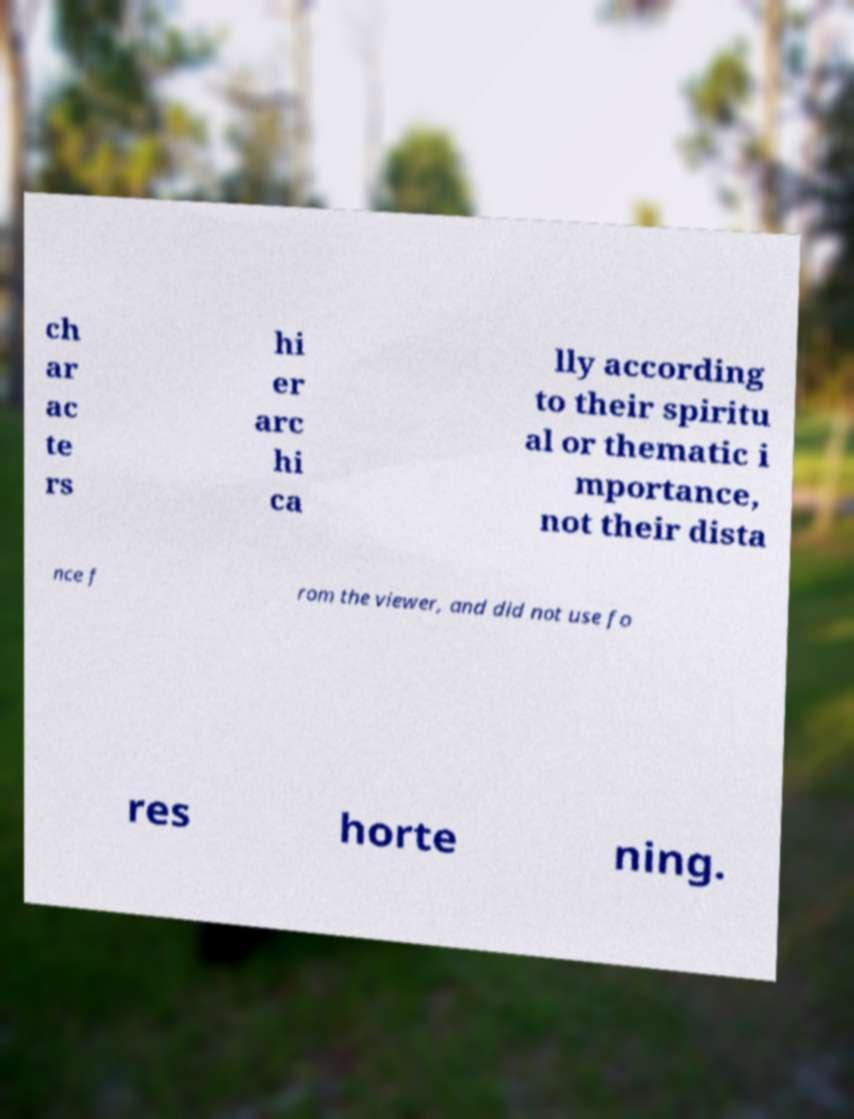For documentation purposes, I need the text within this image transcribed. Could you provide that? ch ar ac te rs hi er arc hi ca lly according to their spiritu al or thematic i mportance, not their dista nce f rom the viewer, and did not use fo res horte ning. 